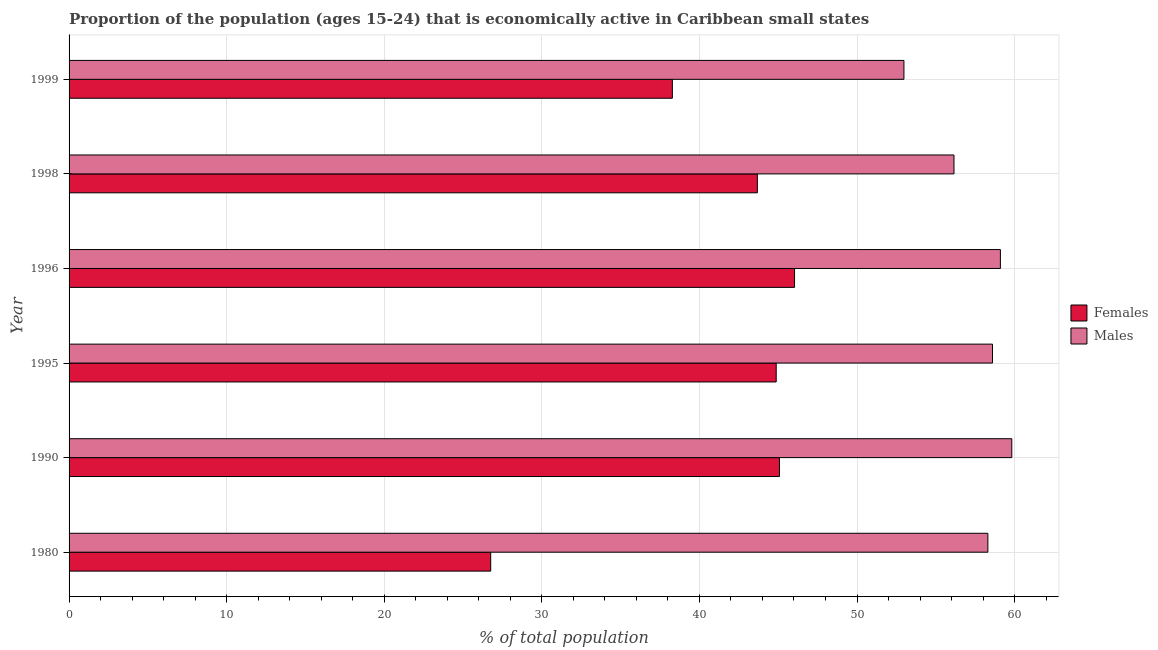Are the number of bars per tick equal to the number of legend labels?
Offer a very short reply. Yes. Are the number of bars on each tick of the Y-axis equal?
Provide a short and direct response. Yes. What is the label of the 5th group of bars from the top?
Make the answer very short. 1990. In how many cases, is the number of bars for a given year not equal to the number of legend labels?
Your response must be concise. 0. What is the percentage of economically active female population in 1998?
Offer a very short reply. 43.68. Across all years, what is the maximum percentage of economically active female population?
Ensure brevity in your answer.  46.04. Across all years, what is the minimum percentage of economically active female population?
Your answer should be compact. 26.76. In which year was the percentage of economically active female population maximum?
Keep it short and to the point. 1996. What is the total percentage of economically active female population in the graph?
Keep it short and to the point. 244.71. What is the difference between the percentage of economically active male population in 1990 and that in 1999?
Provide a succinct answer. 6.84. What is the difference between the percentage of economically active female population in 1980 and the percentage of economically active male population in 1998?
Ensure brevity in your answer.  -29.4. What is the average percentage of economically active male population per year?
Your answer should be compact. 57.49. In the year 1999, what is the difference between the percentage of economically active female population and percentage of economically active male population?
Offer a very short reply. -14.7. What is the ratio of the percentage of economically active male population in 1996 to that in 1999?
Make the answer very short. 1.12. Is the difference between the percentage of economically active male population in 1995 and 1998 greater than the difference between the percentage of economically active female population in 1995 and 1998?
Offer a terse response. Yes. What is the difference between the highest and the second highest percentage of economically active male population?
Your answer should be very brief. 0.72. What is the difference between the highest and the lowest percentage of economically active male population?
Provide a short and direct response. 6.84. What does the 1st bar from the top in 1999 represents?
Keep it short and to the point. Males. What does the 1st bar from the bottom in 1980 represents?
Offer a very short reply. Females. How many years are there in the graph?
Make the answer very short. 6. Where does the legend appear in the graph?
Offer a very short reply. Center right. How many legend labels are there?
Ensure brevity in your answer.  2. What is the title of the graph?
Provide a succinct answer. Proportion of the population (ages 15-24) that is economically active in Caribbean small states. Does "Resident workers" appear as one of the legend labels in the graph?
Make the answer very short. No. What is the label or title of the X-axis?
Offer a terse response. % of total population. What is the label or title of the Y-axis?
Give a very brief answer. Year. What is the % of total population of Females in 1980?
Provide a succinct answer. 26.76. What is the % of total population in Males in 1980?
Offer a very short reply. 58.31. What is the % of total population of Females in 1990?
Provide a short and direct response. 45.08. What is the % of total population of Males in 1990?
Ensure brevity in your answer.  59.82. What is the % of total population of Females in 1995?
Your answer should be compact. 44.87. What is the % of total population of Males in 1995?
Keep it short and to the point. 58.6. What is the % of total population of Females in 1996?
Provide a short and direct response. 46.04. What is the % of total population of Males in 1996?
Ensure brevity in your answer.  59.1. What is the % of total population of Females in 1998?
Your response must be concise. 43.68. What is the % of total population in Males in 1998?
Give a very brief answer. 56.16. What is the % of total population of Females in 1999?
Provide a succinct answer. 38.28. What is the % of total population of Males in 1999?
Keep it short and to the point. 52.98. Across all years, what is the maximum % of total population in Females?
Offer a terse response. 46.04. Across all years, what is the maximum % of total population in Males?
Offer a terse response. 59.82. Across all years, what is the minimum % of total population of Females?
Your answer should be compact. 26.76. Across all years, what is the minimum % of total population in Males?
Your response must be concise. 52.98. What is the total % of total population in Females in the graph?
Make the answer very short. 244.71. What is the total % of total population in Males in the graph?
Offer a very short reply. 344.96. What is the difference between the % of total population in Females in 1980 and that in 1990?
Provide a short and direct response. -18.32. What is the difference between the % of total population in Males in 1980 and that in 1990?
Offer a very short reply. -1.52. What is the difference between the % of total population in Females in 1980 and that in 1995?
Ensure brevity in your answer.  -18.12. What is the difference between the % of total population of Males in 1980 and that in 1995?
Your answer should be very brief. -0.29. What is the difference between the % of total population in Females in 1980 and that in 1996?
Make the answer very short. -19.28. What is the difference between the % of total population of Males in 1980 and that in 1996?
Provide a succinct answer. -0.79. What is the difference between the % of total population of Females in 1980 and that in 1998?
Make the answer very short. -16.92. What is the difference between the % of total population of Males in 1980 and that in 1998?
Your answer should be very brief. 2.15. What is the difference between the % of total population in Females in 1980 and that in 1999?
Your answer should be very brief. -11.53. What is the difference between the % of total population in Males in 1980 and that in 1999?
Provide a succinct answer. 5.33. What is the difference between the % of total population of Females in 1990 and that in 1995?
Your response must be concise. 0.21. What is the difference between the % of total population in Males in 1990 and that in 1995?
Offer a very short reply. 1.22. What is the difference between the % of total population in Females in 1990 and that in 1996?
Your answer should be compact. -0.96. What is the difference between the % of total population of Males in 1990 and that in 1996?
Offer a terse response. 0.72. What is the difference between the % of total population of Females in 1990 and that in 1998?
Keep it short and to the point. 1.4. What is the difference between the % of total population of Males in 1990 and that in 1998?
Your answer should be compact. 3.67. What is the difference between the % of total population in Females in 1990 and that in 1999?
Your response must be concise. 6.8. What is the difference between the % of total population in Males in 1990 and that in 1999?
Your response must be concise. 6.84. What is the difference between the % of total population in Females in 1995 and that in 1996?
Ensure brevity in your answer.  -1.16. What is the difference between the % of total population in Males in 1995 and that in 1996?
Provide a short and direct response. -0.5. What is the difference between the % of total population in Females in 1995 and that in 1998?
Offer a terse response. 1.2. What is the difference between the % of total population in Males in 1995 and that in 1998?
Provide a succinct answer. 2.44. What is the difference between the % of total population in Females in 1995 and that in 1999?
Offer a very short reply. 6.59. What is the difference between the % of total population in Males in 1995 and that in 1999?
Keep it short and to the point. 5.62. What is the difference between the % of total population of Females in 1996 and that in 1998?
Provide a short and direct response. 2.36. What is the difference between the % of total population in Males in 1996 and that in 1998?
Your response must be concise. 2.94. What is the difference between the % of total population in Females in 1996 and that in 1999?
Your response must be concise. 7.75. What is the difference between the % of total population in Males in 1996 and that in 1999?
Ensure brevity in your answer.  6.12. What is the difference between the % of total population in Females in 1998 and that in 1999?
Give a very brief answer. 5.39. What is the difference between the % of total population of Males in 1998 and that in 1999?
Your answer should be very brief. 3.18. What is the difference between the % of total population in Females in 1980 and the % of total population in Males in 1990?
Give a very brief answer. -33.07. What is the difference between the % of total population in Females in 1980 and the % of total population in Males in 1995?
Give a very brief answer. -31.84. What is the difference between the % of total population of Females in 1980 and the % of total population of Males in 1996?
Ensure brevity in your answer.  -32.34. What is the difference between the % of total population of Females in 1980 and the % of total population of Males in 1998?
Ensure brevity in your answer.  -29.4. What is the difference between the % of total population of Females in 1980 and the % of total population of Males in 1999?
Offer a terse response. -26.22. What is the difference between the % of total population of Females in 1990 and the % of total population of Males in 1995?
Offer a terse response. -13.52. What is the difference between the % of total population of Females in 1990 and the % of total population of Males in 1996?
Give a very brief answer. -14.02. What is the difference between the % of total population of Females in 1990 and the % of total population of Males in 1998?
Provide a short and direct response. -11.08. What is the difference between the % of total population of Females in 1990 and the % of total population of Males in 1999?
Provide a succinct answer. -7.9. What is the difference between the % of total population in Females in 1995 and the % of total population in Males in 1996?
Your answer should be very brief. -14.23. What is the difference between the % of total population of Females in 1995 and the % of total population of Males in 1998?
Keep it short and to the point. -11.28. What is the difference between the % of total population in Females in 1995 and the % of total population in Males in 1999?
Give a very brief answer. -8.11. What is the difference between the % of total population in Females in 1996 and the % of total population in Males in 1998?
Keep it short and to the point. -10.12. What is the difference between the % of total population in Females in 1996 and the % of total population in Males in 1999?
Make the answer very short. -6.94. What is the difference between the % of total population in Females in 1998 and the % of total population in Males in 1999?
Give a very brief answer. -9.3. What is the average % of total population of Females per year?
Your answer should be compact. 40.78. What is the average % of total population in Males per year?
Keep it short and to the point. 57.49. In the year 1980, what is the difference between the % of total population of Females and % of total population of Males?
Your response must be concise. -31.55. In the year 1990, what is the difference between the % of total population of Females and % of total population of Males?
Your answer should be compact. -14.74. In the year 1995, what is the difference between the % of total population of Females and % of total population of Males?
Your answer should be compact. -13.73. In the year 1996, what is the difference between the % of total population of Females and % of total population of Males?
Provide a succinct answer. -13.06. In the year 1998, what is the difference between the % of total population of Females and % of total population of Males?
Your answer should be compact. -12.48. In the year 1999, what is the difference between the % of total population of Females and % of total population of Males?
Offer a very short reply. -14.7. What is the ratio of the % of total population in Females in 1980 to that in 1990?
Your answer should be compact. 0.59. What is the ratio of the % of total population of Males in 1980 to that in 1990?
Give a very brief answer. 0.97. What is the ratio of the % of total population of Females in 1980 to that in 1995?
Offer a very short reply. 0.6. What is the ratio of the % of total population of Males in 1980 to that in 1995?
Give a very brief answer. 0.99. What is the ratio of the % of total population of Females in 1980 to that in 1996?
Give a very brief answer. 0.58. What is the ratio of the % of total population in Males in 1980 to that in 1996?
Your answer should be very brief. 0.99. What is the ratio of the % of total population of Females in 1980 to that in 1998?
Your response must be concise. 0.61. What is the ratio of the % of total population of Males in 1980 to that in 1998?
Offer a very short reply. 1.04. What is the ratio of the % of total population of Females in 1980 to that in 1999?
Your answer should be very brief. 0.7. What is the ratio of the % of total population in Males in 1980 to that in 1999?
Offer a terse response. 1.1. What is the ratio of the % of total population in Males in 1990 to that in 1995?
Provide a short and direct response. 1.02. What is the ratio of the % of total population of Females in 1990 to that in 1996?
Offer a very short reply. 0.98. What is the ratio of the % of total population in Males in 1990 to that in 1996?
Offer a terse response. 1.01. What is the ratio of the % of total population in Females in 1990 to that in 1998?
Give a very brief answer. 1.03. What is the ratio of the % of total population in Males in 1990 to that in 1998?
Your answer should be very brief. 1.07. What is the ratio of the % of total population in Females in 1990 to that in 1999?
Offer a terse response. 1.18. What is the ratio of the % of total population of Males in 1990 to that in 1999?
Your answer should be very brief. 1.13. What is the ratio of the % of total population of Females in 1995 to that in 1996?
Your answer should be very brief. 0.97. What is the ratio of the % of total population of Females in 1995 to that in 1998?
Your response must be concise. 1.03. What is the ratio of the % of total population of Males in 1995 to that in 1998?
Keep it short and to the point. 1.04. What is the ratio of the % of total population in Females in 1995 to that in 1999?
Your answer should be very brief. 1.17. What is the ratio of the % of total population of Males in 1995 to that in 1999?
Make the answer very short. 1.11. What is the ratio of the % of total population in Females in 1996 to that in 1998?
Provide a succinct answer. 1.05. What is the ratio of the % of total population in Males in 1996 to that in 1998?
Keep it short and to the point. 1.05. What is the ratio of the % of total population of Females in 1996 to that in 1999?
Give a very brief answer. 1.2. What is the ratio of the % of total population of Males in 1996 to that in 1999?
Keep it short and to the point. 1.12. What is the ratio of the % of total population in Females in 1998 to that in 1999?
Provide a succinct answer. 1.14. What is the ratio of the % of total population in Males in 1998 to that in 1999?
Provide a short and direct response. 1.06. What is the difference between the highest and the second highest % of total population of Females?
Ensure brevity in your answer.  0.96. What is the difference between the highest and the second highest % of total population in Males?
Your answer should be very brief. 0.72. What is the difference between the highest and the lowest % of total population of Females?
Keep it short and to the point. 19.28. What is the difference between the highest and the lowest % of total population of Males?
Your answer should be very brief. 6.84. 